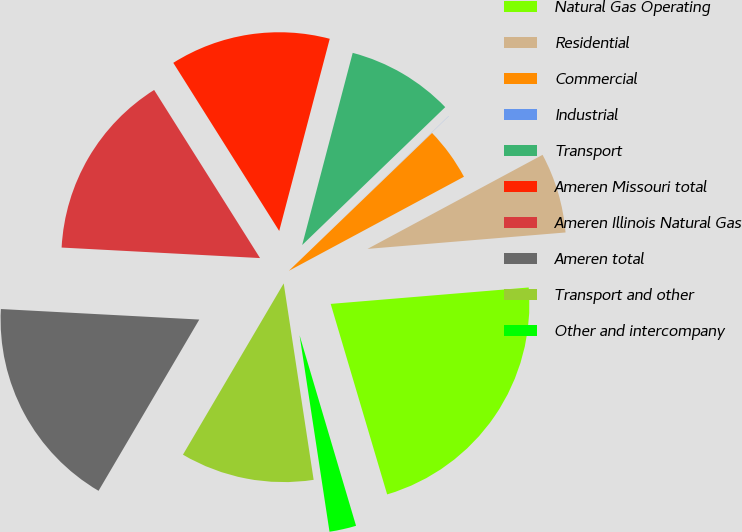Convert chart. <chart><loc_0><loc_0><loc_500><loc_500><pie_chart><fcel>Natural Gas Operating<fcel>Residential<fcel>Commercial<fcel>Industrial<fcel>Transport<fcel>Ameren Missouri total<fcel>Ameren Illinois Natural Gas<fcel>Ameren total<fcel>Transport and other<fcel>Other and intercompany<nl><fcel>21.73%<fcel>6.53%<fcel>4.35%<fcel>0.01%<fcel>8.7%<fcel>13.04%<fcel>15.21%<fcel>17.38%<fcel>10.87%<fcel>2.18%<nl></chart> 